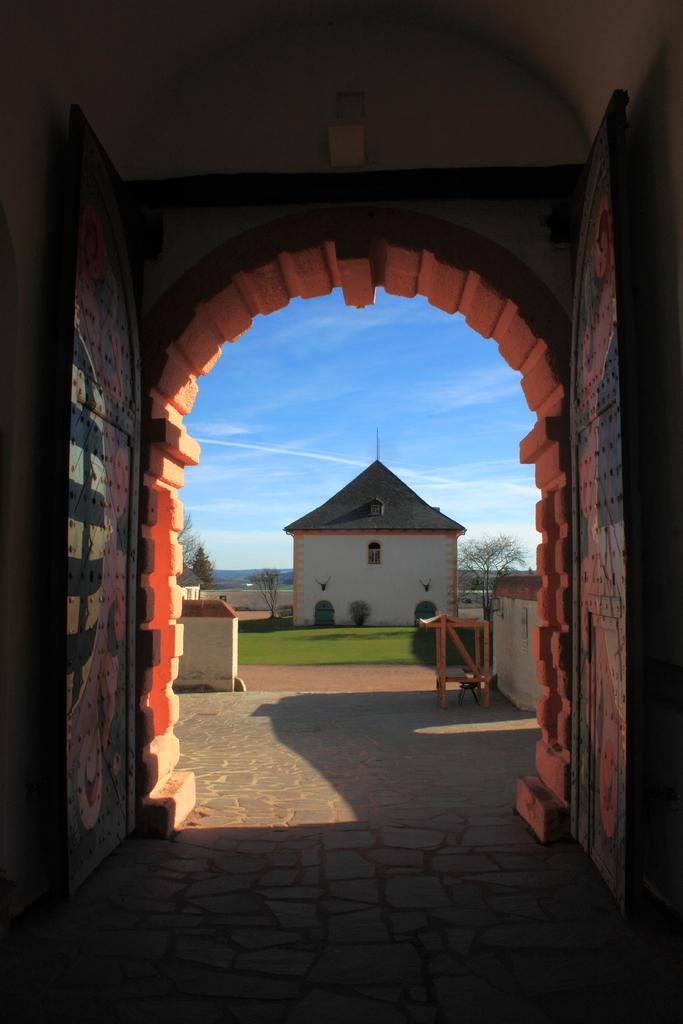What is the main structure visible in the image? There is a building in the image. What are the walls made of in the image? The walls are part of the building, but the material is not specified in the facts. What type of vegetation can be seen in the image? There are trees and grass in the image. What is visible in the sky in the image? There are clouds in the sky in the image. Where is the basketball located in the image? There is no basketball present in the image. What type of bag is hanging on the door in the image? There is no bag or door mentioned in the image; only a building, walls, grass, trees, and clouds are described. 